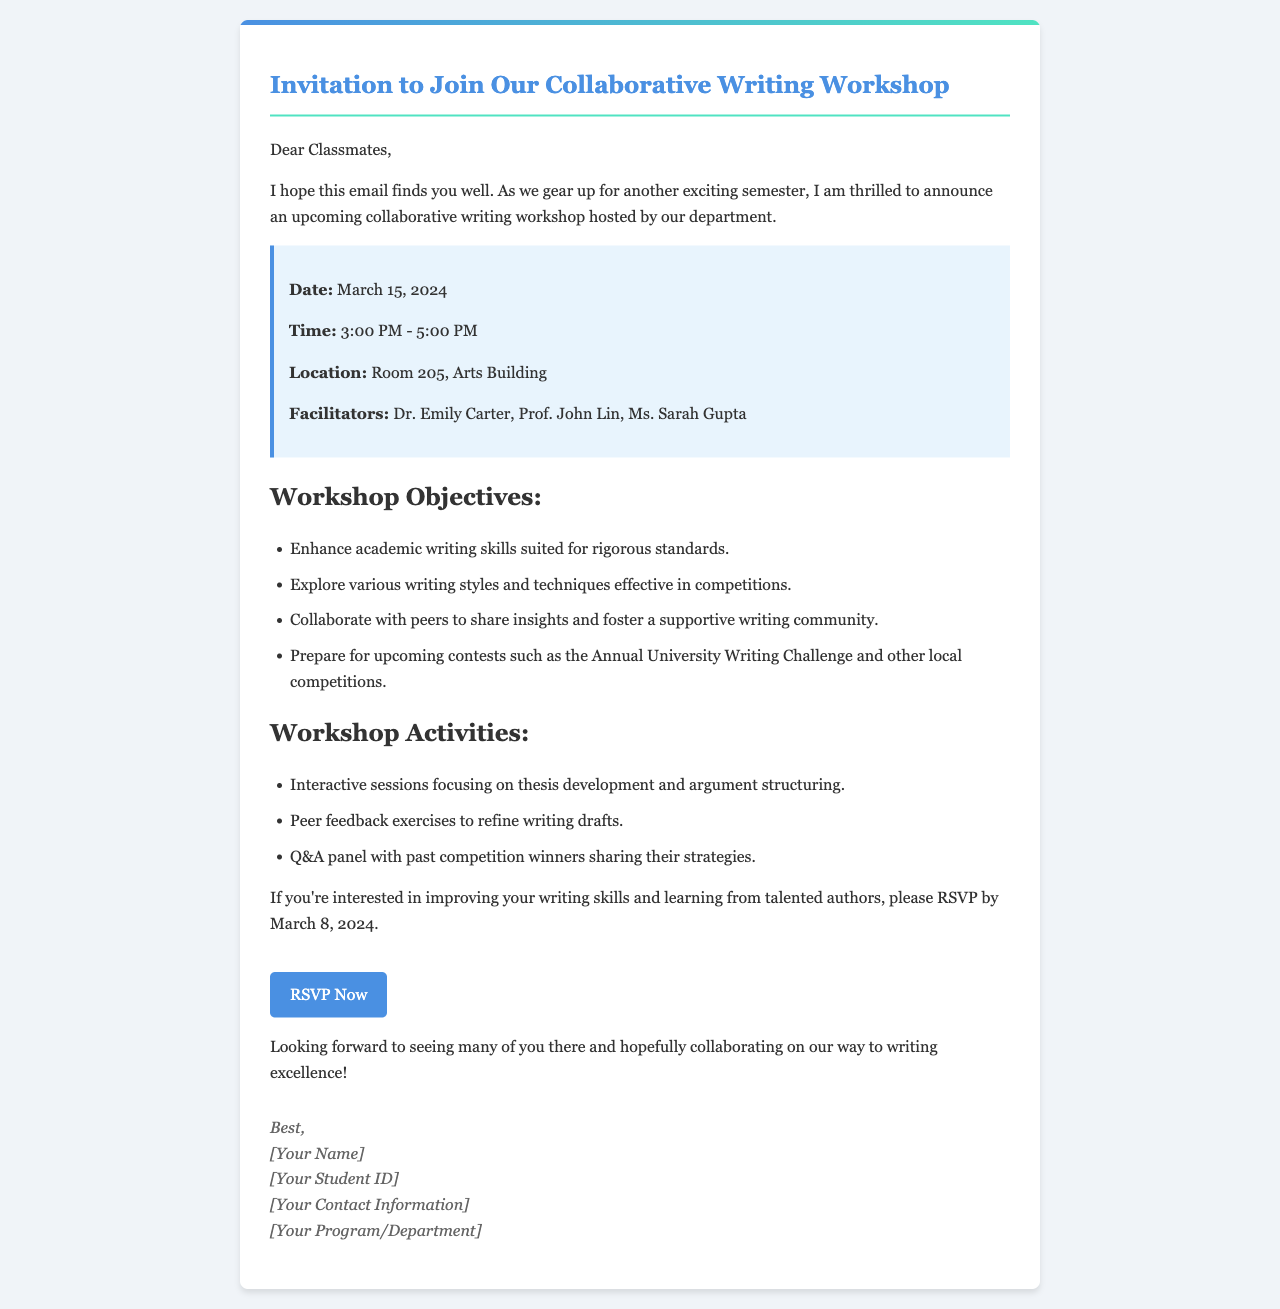What is the date of the workshop? The date of the workshop is explicitly mentioned in the document.
Answer: March 15, 2024 What time will the workshop take place? The time is specified in the details section of the email.
Answer: 3:00 PM - 5:00 PM What is the location of the workshop? The location is clearly stated in the email details.
Answer: Room 205, Arts Building Who are the facilitators of the workshop? The facilitators are listed in the details section.
Answer: Dr. Emily Carter, Prof. John Lin, Ms. Sarah Gupta What is one objective of the workshop? The objectives are outlined in a bullet list in the document.
Answer: Enhance academic writing skills What is one activity planned for the workshop? Activities are mentioned in the email, and one is highlighted with documentation.
Answer: Peer feedback exercises By when do participants need to RSVP? The RSVP deadline is mentioned towards the end of the email.
Answer: March 8, 2024 What is the name of the contest referenced in the workshop? The contest is specifically mentioned in the objectives.
Answer: Annual University Writing Challenge What kind of community does the workshop aim to foster? The aim of the workshop regarding community building is found within the objectives.
Answer: Supportive writing community Who is the sender of the email? The signature area suggests the information about the sender, indicating who will be signing off.
Answer: [Your Name] 